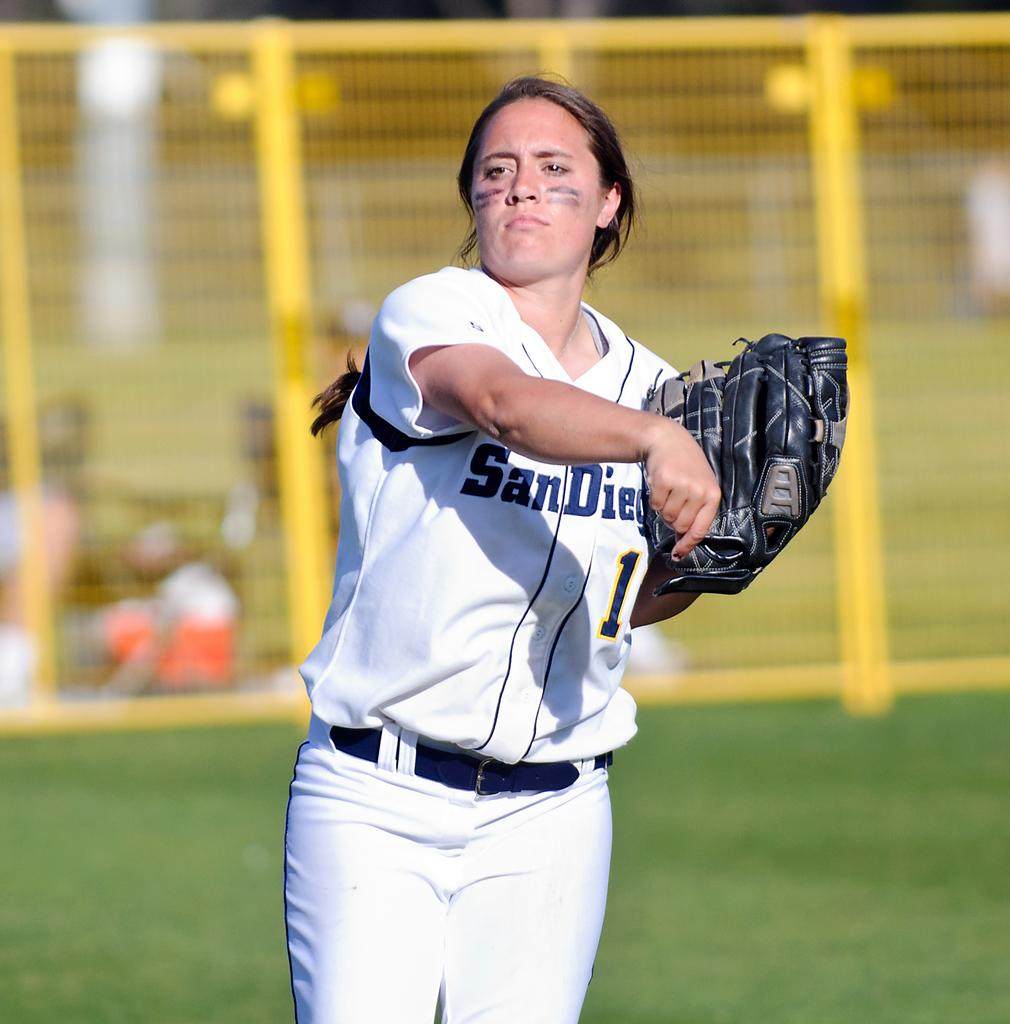<image>
Describe the image concisely. a lady that is wearing a San Diego jersey 